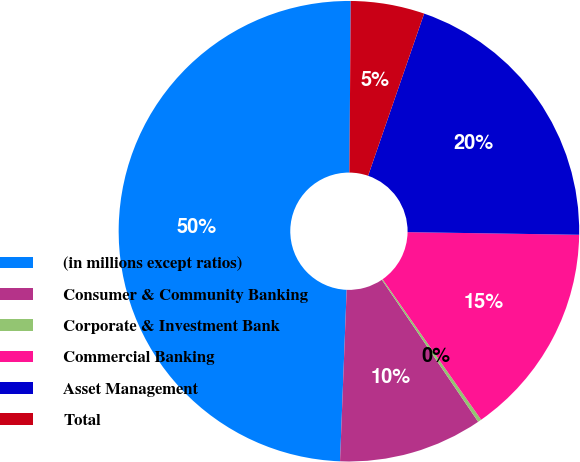Convert chart to OTSL. <chart><loc_0><loc_0><loc_500><loc_500><pie_chart><fcel>(in millions except ratios)<fcel>Consumer & Community Banking<fcel>Corporate & Investment Bank<fcel>Commercial Banking<fcel>Asset Management<fcel>Total<nl><fcel>49.51%<fcel>10.1%<fcel>0.25%<fcel>15.02%<fcel>19.95%<fcel>5.17%<nl></chart> 